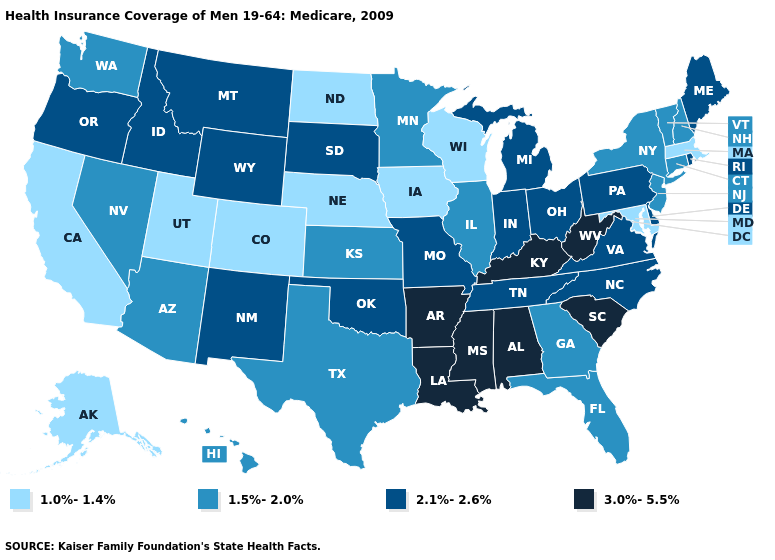Does Ohio have the highest value in the MidWest?
Be succinct. Yes. Does Idaho have the lowest value in the West?
Concise answer only. No. Does Ohio have the highest value in the MidWest?
Give a very brief answer. Yes. Among the states that border Connecticut , does Massachusetts have the lowest value?
Quick response, please. Yes. What is the value of New Hampshire?
Concise answer only. 1.5%-2.0%. Name the states that have a value in the range 1.0%-1.4%?
Give a very brief answer. Alaska, California, Colorado, Iowa, Maryland, Massachusetts, Nebraska, North Dakota, Utah, Wisconsin. Name the states that have a value in the range 1.0%-1.4%?
Write a very short answer. Alaska, California, Colorado, Iowa, Maryland, Massachusetts, Nebraska, North Dakota, Utah, Wisconsin. Name the states that have a value in the range 3.0%-5.5%?
Quick response, please. Alabama, Arkansas, Kentucky, Louisiana, Mississippi, South Carolina, West Virginia. Name the states that have a value in the range 1.5%-2.0%?
Write a very short answer. Arizona, Connecticut, Florida, Georgia, Hawaii, Illinois, Kansas, Minnesota, Nevada, New Hampshire, New Jersey, New York, Texas, Vermont, Washington. Does South Carolina have a lower value than Arizona?
Keep it brief. No. Is the legend a continuous bar?
Short answer required. No. Does Illinois have the lowest value in the MidWest?
Quick response, please. No. What is the lowest value in the USA?
Keep it brief. 1.0%-1.4%. What is the highest value in states that border Washington?
Answer briefly. 2.1%-2.6%. What is the lowest value in states that border Delaware?
Short answer required. 1.0%-1.4%. 